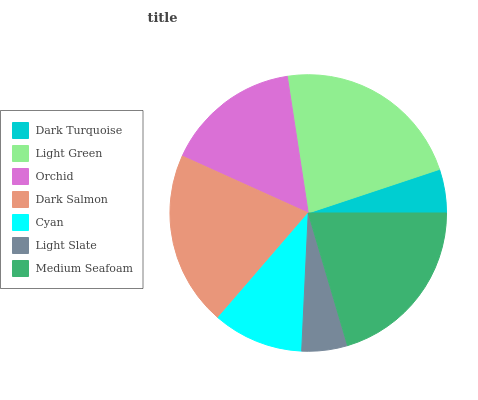Is Dark Turquoise the minimum?
Answer yes or no. Yes. Is Light Green the maximum?
Answer yes or no. Yes. Is Orchid the minimum?
Answer yes or no. No. Is Orchid the maximum?
Answer yes or no. No. Is Light Green greater than Orchid?
Answer yes or no. Yes. Is Orchid less than Light Green?
Answer yes or no. Yes. Is Orchid greater than Light Green?
Answer yes or no. No. Is Light Green less than Orchid?
Answer yes or no. No. Is Orchid the high median?
Answer yes or no. Yes. Is Orchid the low median?
Answer yes or no. Yes. Is Light Slate the high median?
Answer yes or no. No. Is Light Green the low median?
Answer yes or no. No. 